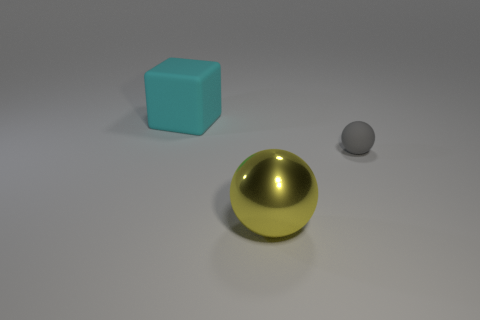Add 1 large metal spheres. How many objects exist? 4 Subtract all cubes. How many objects are left? 2 Add 1 blocks. How many blocks are left? 2 Add 1 big yellow rubber spheres. How many big yellow rubber spheres exist? 1 Subtract 0 yellow cylinders. How many objects are left? 3 Subtract all tiny yellow objects. Subtract all big cubes. How many objects are left? 2 